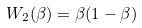Convert formula to latex. <formula><loc_0><loc_0><loc_500><loc_500>W _ { 2 } ( \beta ) = \beta ( 1 - \beta )</formula> 